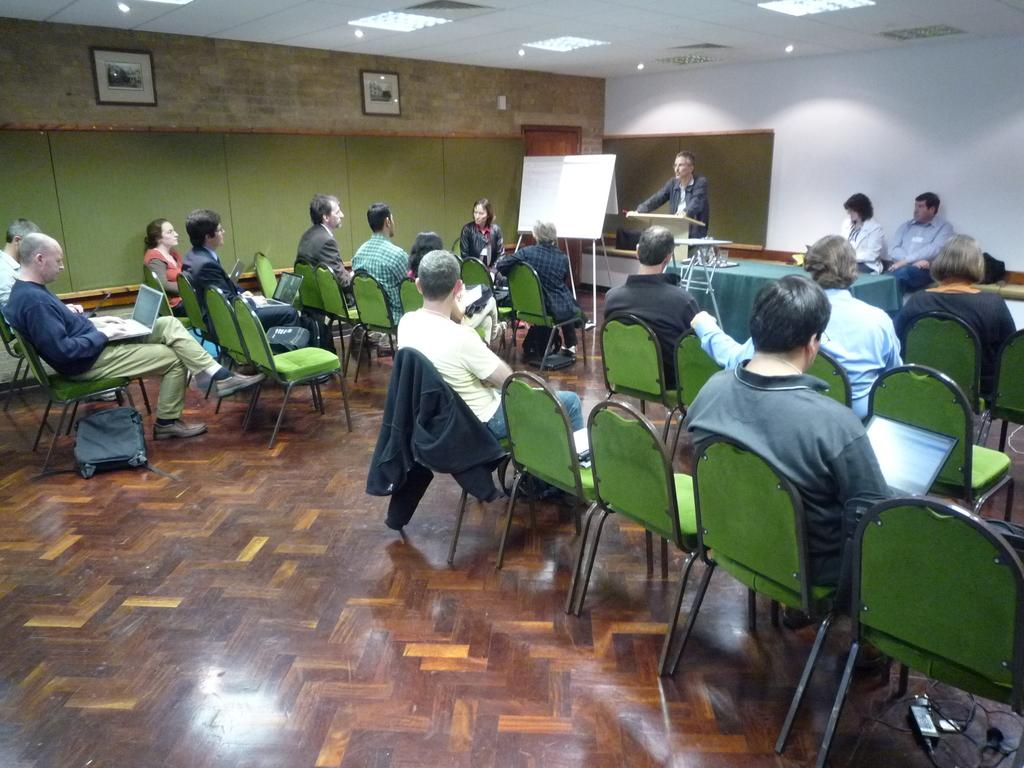What are the people in the room doing? The people in the room are sitting on chairs. Can you describe the furniture in the room? There are chairs, a desk, and two frames on the wall. What is the purpose of the whiteboard in the room? The whiteboard in the room is likely used for writing or displaying information. What time is displayed on the clock in the room? There is no clock present in the image, so the time cannot be determined. 